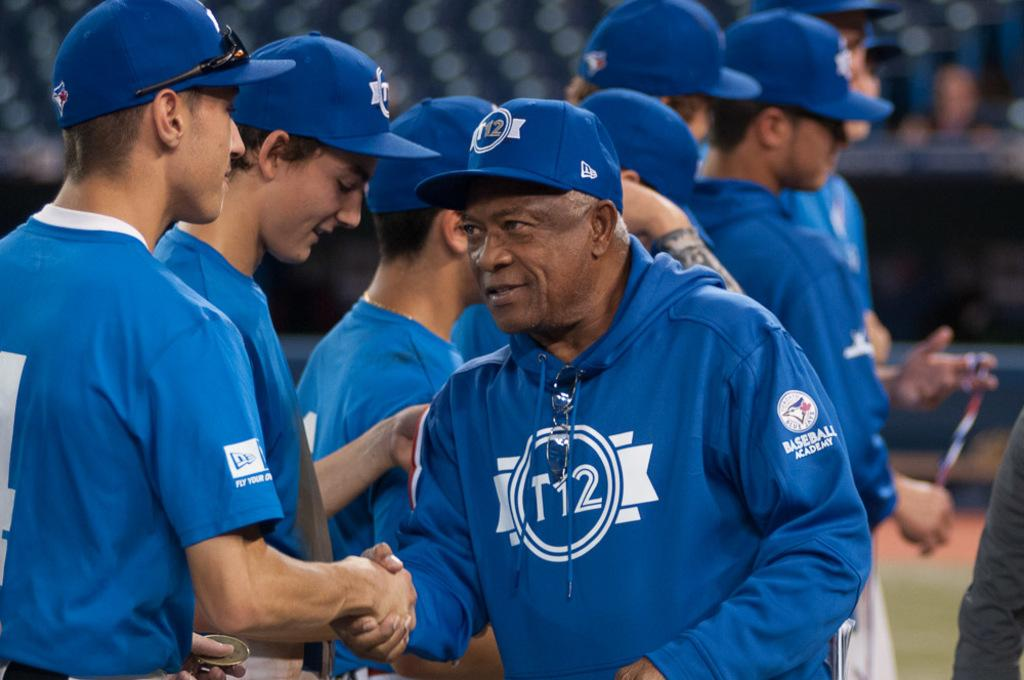<image>
Provide a brief description of the given image. Man wearing a blue hoodie which says T12 on it. 